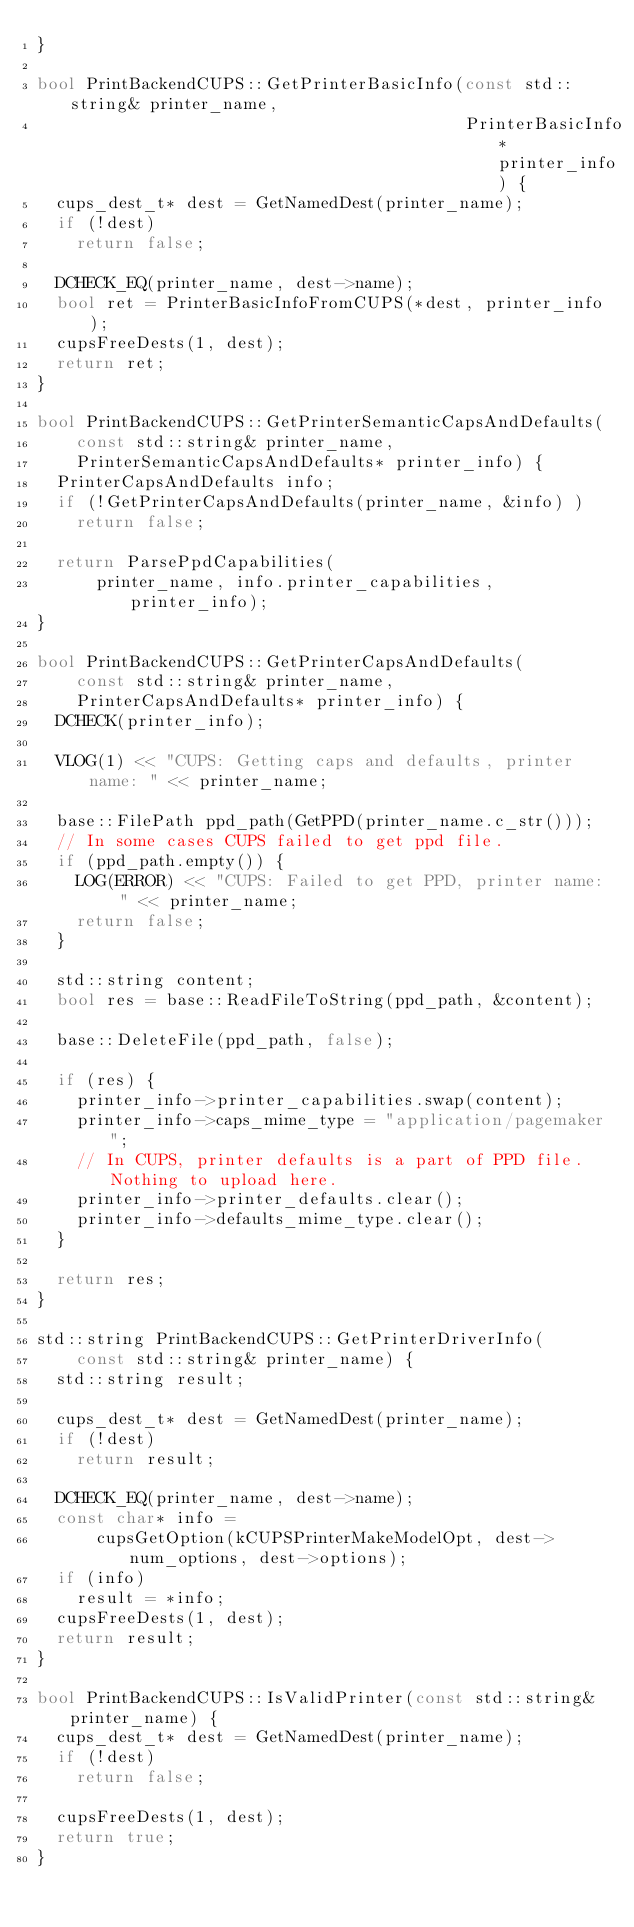Convert code to text. <code><loc_0><loc_0><loc_500><loc_500><_C++_>}

bool PrintBackendCUPS::GetPrinterBasicInfo(const std::string& printer_name,
                                           PrinterBasicInfo* printer_info) {
  cups_dest_t* dest = GetNamedDest(printer_name);
  if (!dest)
    return false;

  DCHECK_EQ(printer_name, dest->name);
  bool ret = PrinterBasicInfoFromCUPS(*dest, printer_info);
  cupsFreeDests(1, dest);
  return ret;
}

bool PrintBackendCUPS::GetPrinterSemanticCapsAndDefaults(
    const std::string& printer_name,
    PrinterSemanticCapsAndDefaults* printer_info) {
  PrinterCapsAndDefaults info;
  if (!GetPrinterCapsAndDefaults(printer_name, &info) )
    return false;

  return ParsePpdCapabilities(
      printer_name, info.printer_capabilities, printer_info);
}

bool PrintBackendCUPS::GetPrinterCapsAndDefaults(
    const std::string& printer_name,
    PrinterCapsAndDefaults* printer_info) {
  DCHECK(printer_info);

  VLOG(1) << "CUPS: Getting caps and defaults, printer name: " << printer_name;

  base::FilePath ppd_path(GetPPD(printer_name.c_str()));
  // In some cases CUPS failed to get ppd file.
  if (ppd_path.empty()) {
    LOG(ERROR) << "CUPS: Failed to get PPD, printer name: " << printer_name;
    return false;
  }

  std::string content;
  bool res = base::ReadFileToString(ppd_path, &content);

  base::DeleteFile(ppd_path, false);

  if (res) {
    printer_info->printer_capabilities.swap(content);
    printer_info->caps_mime_type = "application/pagemaker";
    // In CUPS, printer defaults is a part of PPD file. Nothing to upload here.
    printer_info->printer_defaults.clear();
    printer_info->defaults_mime_type.clear();
  }

  return res;
}

std::string PrintBackendCUPS::GetPrinterDriverInfo(
    const std::string& printer_name) {
  std::string result;

  cups_dest_t* dest = GetNamedDest(printer_name);
  if (!dest)
    return result;

  DCHECK_EQ(printer_name, dest->name);
  const char* info =
      cupsGetOption(kCUPSPrinterMakeModelOpt, dest->num_options, dest->options);
  if (info)
    result = *info;
  cupsFreeDests(1, dest);
  return result;
}

bool PrintBackendCUPS::IsValidPrinter(const std::string& printer_name) {
  cups_dest_t* dest = GetNamedDest(printer_name);
  if (!dest)
    return false;

  cupsFreeDests(1, dest);
  return true;
}
</code> 